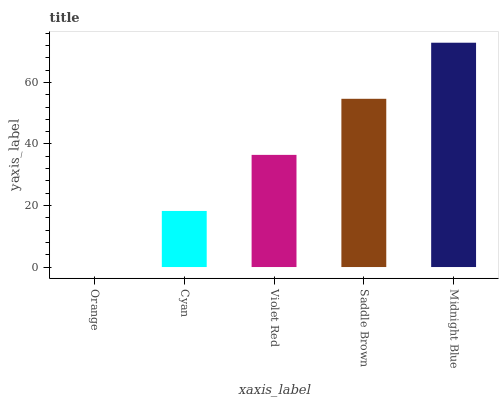Is Orange the minimum?
Answer yes or no. Yes. Is Midnight Blue the maximum?
Answer yes or no. Yes. Is Cyan the minimum?
Answer yes or no. No. Is Cyan the maximum?
Answer yes or no. No. Is Cyan greater than Orange?
Answer yes or no. Yes. Is Orange less than Cyan?
Answer yes or no. Yes. Is Orange greater than Cyan?
Answer yes or no. No. Is Cyan less than Orange?
Answer yes or no. No. Is Violet Red the high median?
Answer yes or no. Yes. Is Violet Red the low median?
Answer yes or no. Yes. Is Midnight Blue the high median?
Answer yes or no. No. Is Orange the low median?
Answer yes or no. No. 